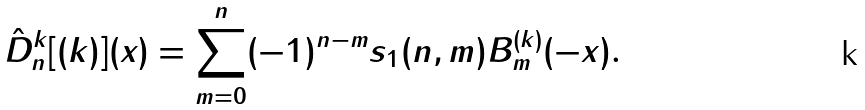<formula> <loc_0><loc_0><loc_500><loc_500>\hat { D } _ { n } ^ { k } [ ( k ) ] ( x ) = \sum _ { m = 0 } ^ { n } ( - 1 ) ^ { n - m } s _ { 1 } ( n , m ) B _ { m } ^ { ( k ) } ( - x ) .</formula> 